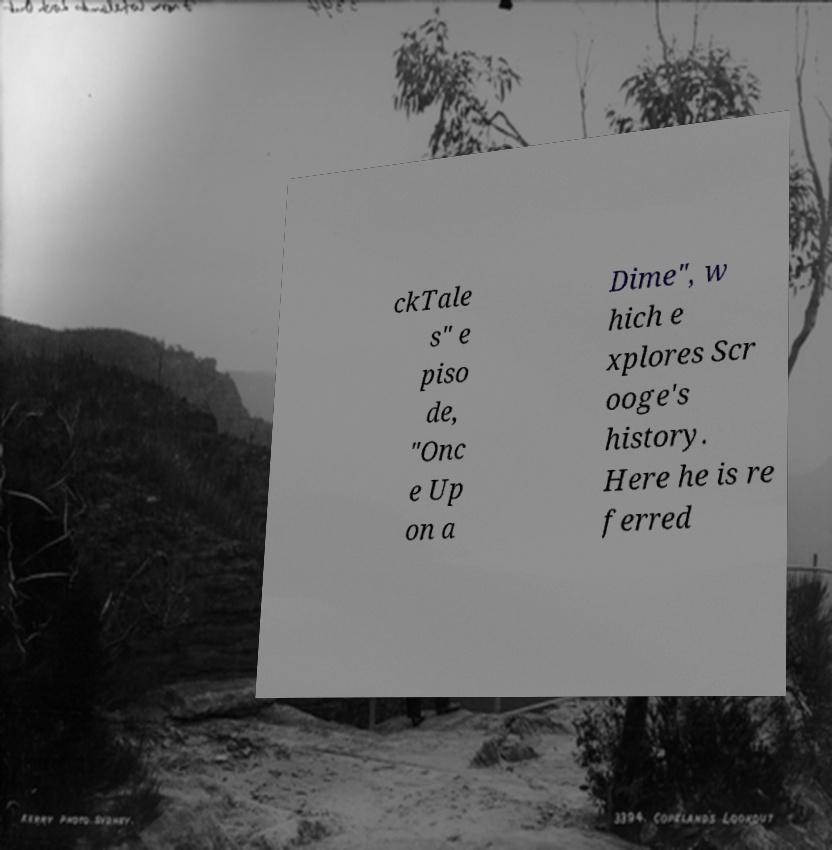There's text embedded in this image that I need extracted. Can you transcribe it verbatim? ckTale s" e piso de, "Onc e Up on a Dime", w hich e xplores Scr ooge's history. Here he is re ferred 